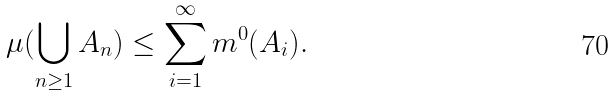<formula> <loc_0><loc_0><loc_500><loc_500>\mu ( \bigcup _ { n \geq 1 } A _ { n } ) \leq \sum _ { i = 1 } ^ { \infty } m ^ { 0 } ( A _ { i } ) .</formula> 